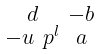Convert formula to latex. <formula><loc_0><loc_0><loc_500><loc_500>\begin{smallmatrix} d & - b \\ - u \ p ^ { l } & a \end{smallmatrix}</formula> 